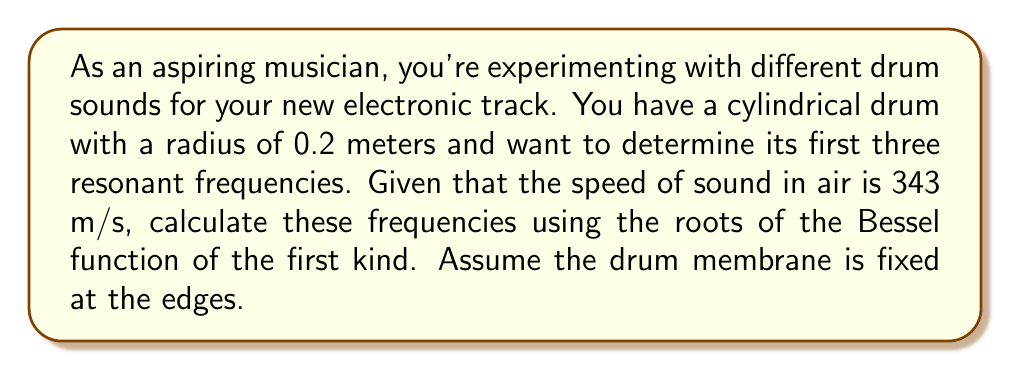What is the answer to this math problem? To solve this problem, we need to use the theory of vibrating membranes and Bessel functions. The resonant frequencies of a circular membrane (like a drum head) are given by the equation:

$$ f_{mn} = \frac{c}{2\pi a} \alpha_{mn} $$

Where:
- $f_{mn}$ is the resonant frequency
- $c$ is the speed of sound in air (343 m/s)
- $a$ is the radius of the drum (0.2 m)
- $\alpha_{mn}$ are the roots of the Bessel function of the first kind

The roots $\alpha_{mn}$ are tabulated values. For the first three modes, we have:
- $\alpha_{01} \approx 2.4048$
- $\alpha_{11} \approx 3.8317$
- $\alpha_{21} \approx 5.1356$

Let's calculate each frequency:

1. First resonant frequency:
   $$ f_{01} = \frac{343}{2\pi(0.2)} (2.4048) = 651.63 \text{ Hz} $$

2. Second resonant frequency:
   $$ f_{11} = \frac{343}{2\pi(0.2)} (3.8317) = 1038.20 \text{ Hz} $$

3. Third resonant frequency:
   $$ f_{21} = \frac{343}{2\pi(0.2)} (5.1356) = 1391.62 \text{ Hz} $$

These frequencies represent the fundamental tone (f₀₁) and the next two overtones (f₁₁ and f₂₁) of the drum.
Answer: The first three resonant frequencies of the cylindrical drum are:
1. $f_{01} \approx 651.63 \text{ Hz}$
2. $f_{11} \approx 1038.20 \text{ Hz}$
3. $f_{21} \approx 1391.62 \text{ Hz}$ 